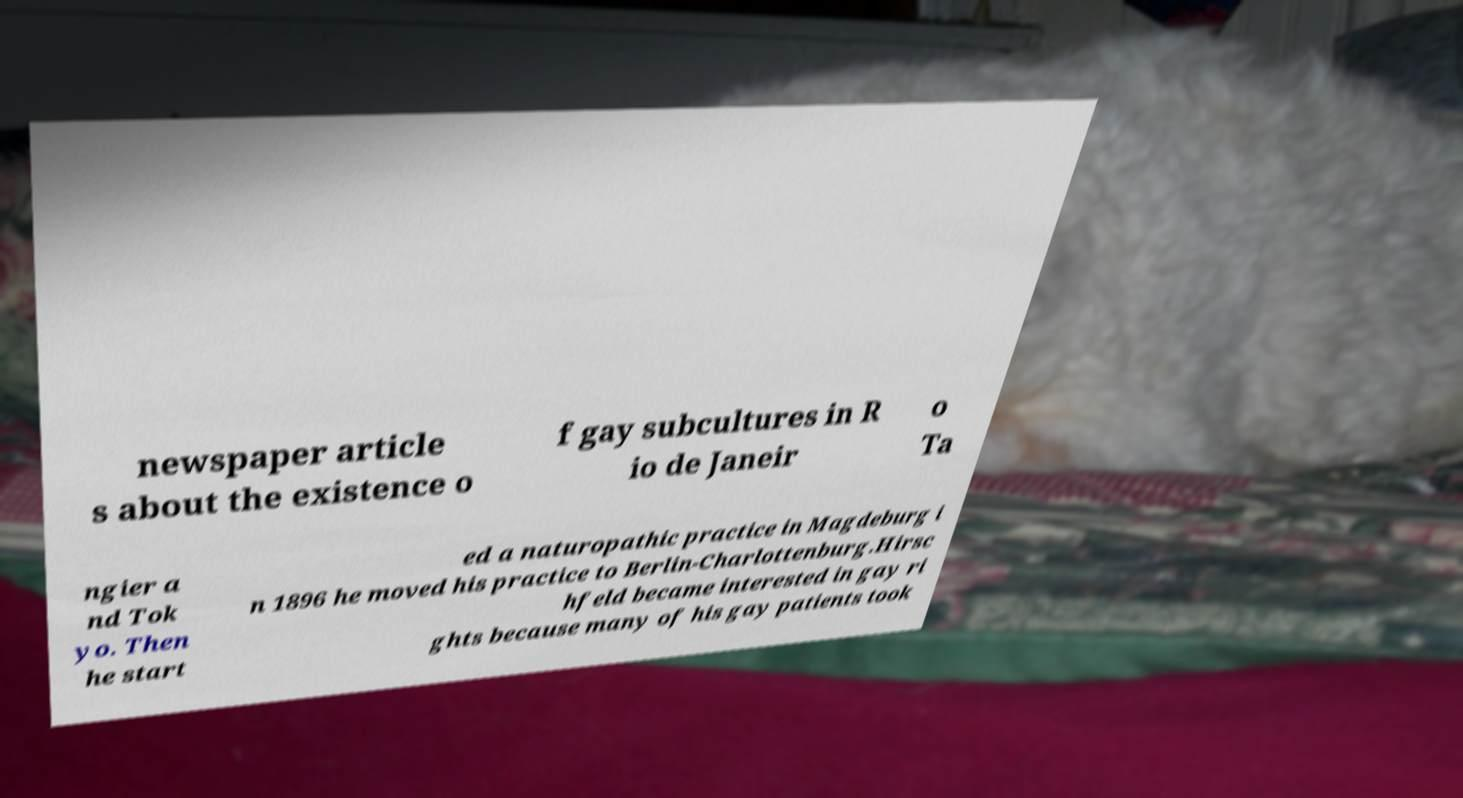Can you read and provide the text displayed in the image?This photo seems to have some interesting text. Can you extract and type it out for me? newspaper article s about the existence o f gay subcultures in R io de Janeir o Ta ngier a nd Tok yo. Then he start ed a naturopathic practice in Magdeburg i n 1896 he moved his practice to Berlin-Charlottenburg.Hirsc hfeld became interested in gay ri ghts because many of his gay patients took 